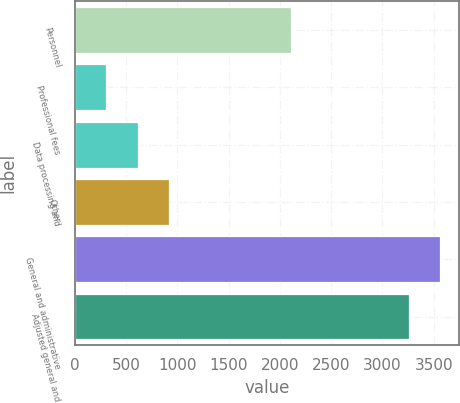Convert chart. <chart><loc_0><loc_0><loc_500><loc_500><bar_chart><fcel>Personnel<fcel>Professional fees<fcel>Data processing and<fcel>Other<fcel>General and administrative<fcel>Adjusted general and<nl><fcel>2105<fcel>310<fcel>613.1<fcel>916.2<fcel>3565.1<fcel>3262<nl></chart> 